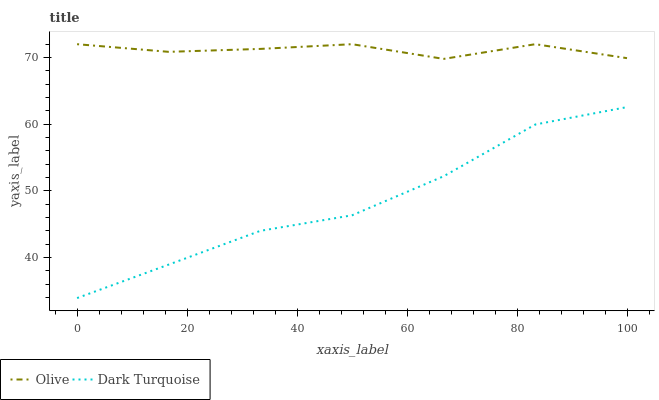Does Dark Turquoise have the minimum area under the curve?
Answer yes or no. Yes. Does Olive have the maximum area under the curve?
Answer yes or no. Yes. Does Dark Turquoise have the maximum area under the curve?
Answer yes or no. No. Is Dark Turquoise the smoothest?
Answer yes or no. Yes. Is Olive the roughest?
Answer yes or no. Yes. Is Dark Turquoise the roughest?
Answer yes or no. No. Does Dark Turquoise have the lowest value?
Answer yes or no. Yes. Does Olive have the highest value?
Answer yes or no. Yes. Does Dark Turquoise have the highest value?
Answer yes or no. No. Is Dark Turquoise less than Olive?
Answer yes or no. Yes. Is Olive greater than Dark Turquoise?
Answer yes or no. Yes. Does Dark Turquoise intersect Olive?
Answer yes or no. No. 